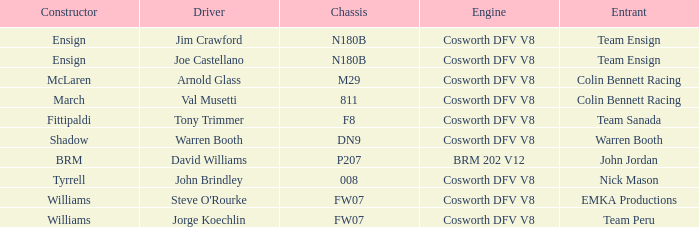Who built the Jim Crawford car? Ensign. 